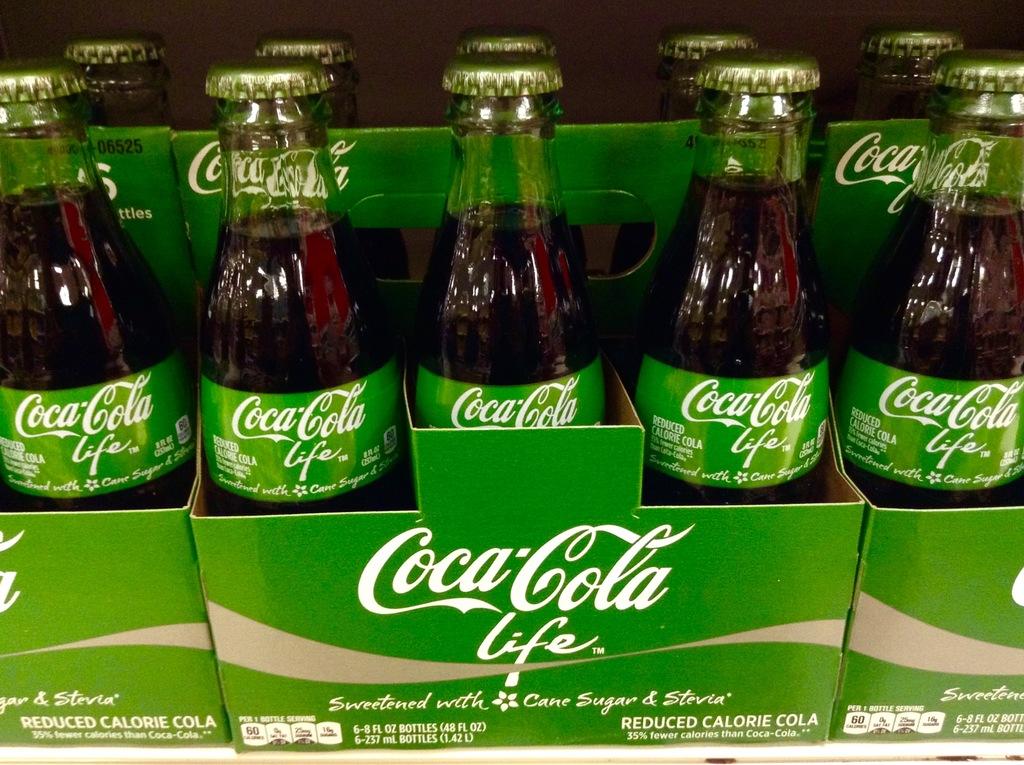What brand of drink is this?
Give a very brief answer. Coca cola. 